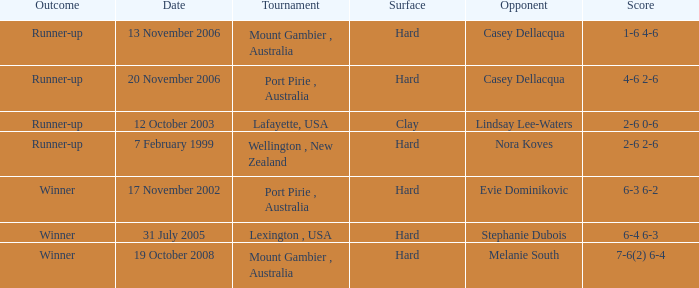When is an Opponent of evie dominikovic? 17 November 2002. 